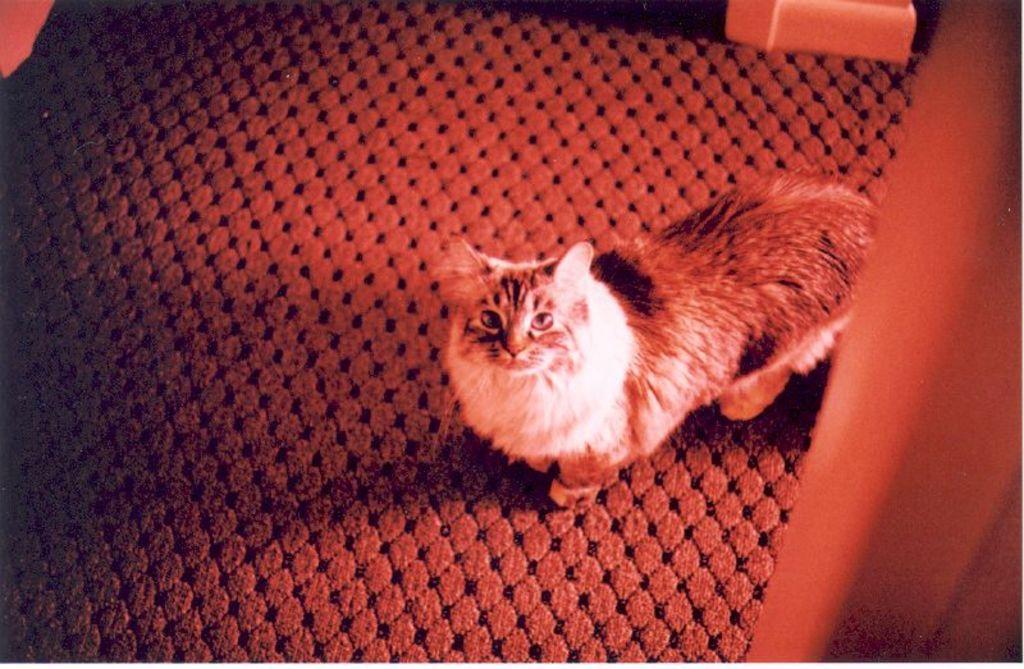How would you summarize this image in a sentence or two? In this image I can see a car on the mat which is placed on the floor. On the right side there is a wooden object. At the top there is an object placed on the floor. 